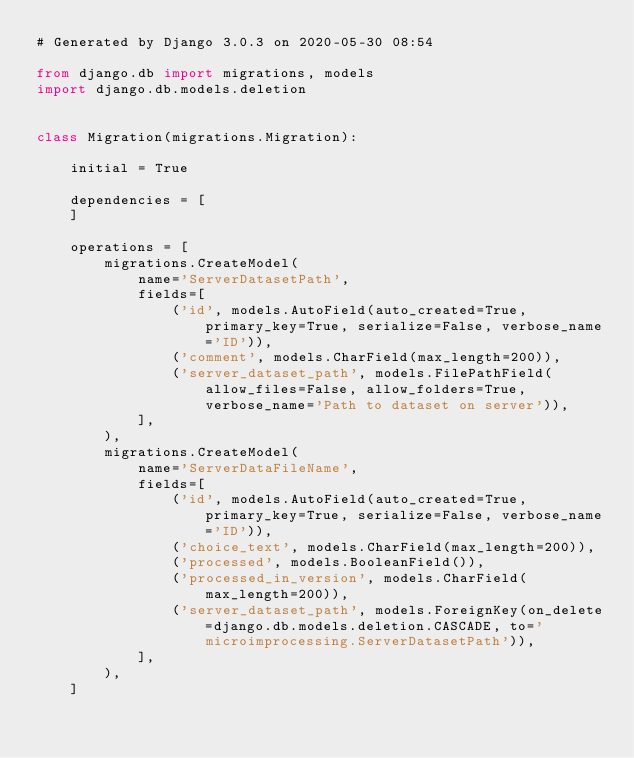<code> <loc_0><loc_0><loc_500><loc_500><_Python_># Generated by Django 3.0.3 on 2020-05-30 08:54

from django.db import migrations, models
import django.db.models.deletion


class Migration(migrations.Migration):

    initial = True

    dependencies = [
    ]

    operations = [
        migrations.CreateModel(
            name='ServerDatasetPath',
            fields=[
                ('id', models.AutoField(auto_created=True, primary_key=True, serialize=False, verbose_name='ID')),
                ('comment', models.CharField(max_length=200)),
                ('server_dataset_path', models.FilePathField(allow_files=False, allow_folders=True, verbose_name='Path to dataset on server')),
            ],
        ),
        migrations.CreateModel(
            name='ServerDataFileName',
            fields=[
                ('id', models.AutoField(auto_created=True, primary_key=True, serialize=False, verbose_name='ID')),
                ('choice_text', models.CharField(max_length=200)),
                ('processed', models.BooleanField()),
                ('processed_in_version', models.CharField(max_length=200)),
                ('server_dataset_path', models.ForeignKey(on_delete=django.db.models.deletion.CASCADE, to='microimprocessing.ServerDatasetPath')),
            ],
        ),
    ]
</code> 